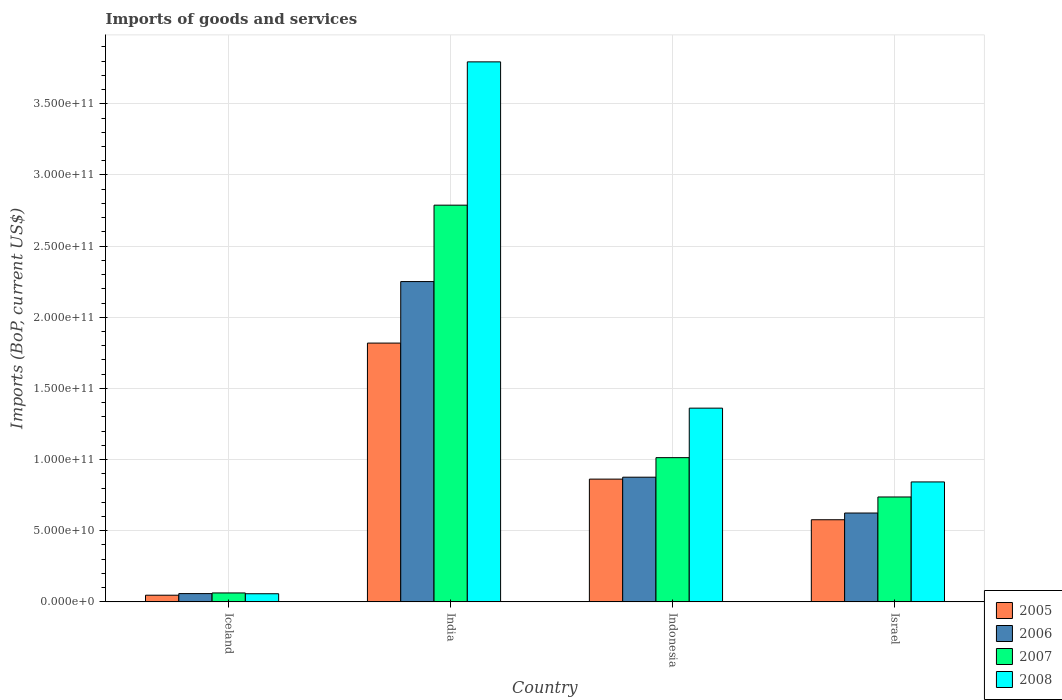What is the label of the 2nd group of bars from the left?
Your response must be concise. India. In how many cases, is the number of bars for a given country not equal to the number of legend labels?
Offer a terse response. 0. What is the amount spent on imports in 2006 in Iceland?
Your answer should be compact. 5.82e+09. Across all countries, what is the maximum amount spent on imports in 2007?
Ensure brevity in your answer.  2.79e+11. Across all countries, what is the minimum amount spent on imports in 2005?
Provide a succinct answer. 4.68e+09. In which country was the amount spent on imports in 2005 maximum?
Offer a very short reply. India. What is the total amount spent on imports in 2007 in the graph?
Provide a succinct answer. 4.60e+11. What is the difference between the amount spent on imports in 2005 in Iceland and that in Israel?
Your response must be concise. -5.30e+1. What is the difference between the amount spent on imports in 2008 in Iceland and the amount spent on imports in 2005 in Israel?
Ensure brevity in your answer.  -5.20e+1. What is the average amount spent on imports in 2007 per country?
Your response must be concise. 1.15e+11. What is the difference between the amount spent on imports of/in 2008 and amount spent on imports of/in 2007 in Israel?
Provide a short and direct response. 1.06e+1. What is the ratio of the amount spent on imports in 2008 in Indonesia to that in Israel?
Offer a terse response. 1.62. What is the difference between the highest and the second highest amount spent on imports in 2008?
Ensure brevity in your answer.  2.43e+11. What is the difference between the highest and the lowest amount spent on imports in 2008?
Make the answer very short. 3.74e+11. Is the sum of the amount spent on imports in 2005 in Iceland and India greater than the maximum amount spent on imports in 2006 across all countries?
Offer a very short reply. No. Is it the case that in every country, the sum of the amount spent on imports in 2008 and amount spent on imports in 2007 is greater than the sum of amount spent on imports in 2006 and amount spent on imports in 2005?
Ensure brevity in your answer.  No. Is it the case that in every country, the sum of the amount spent on imports in 2008 and amount spent on imports in 2006 is greater than the amount spent on imports in 2005?
Make the answer very short. Yes. Does the graph contain grids?
Make the answer very short. Yes. How many legend labels are there?
Ensure brevity in your answer.  4. What is the title of the graph?
Keep it short and to the point. Imports of goods and services. Does "1990" appear as one of the legend labels in the graph?
Your answer should be very brief. No. What is the label or title of the X-axis?
Your answer should be very brief. Country. What is the label or title of the Y-axis?
Keep it short and to the point. Imports (BoP, current US$). What is the Imports (BoP, current US$) in 2005 in Iceland?
Keep it short and to the point. 4.68e+09. What is the Imports (BoP, current US$) of 2006 in Iceland?
Your answer should be compact. 5.82e+09. What is the Imports (BoP, current US$) in 2007 in Iceland?
Your answer should be very brief. 6.27e+09. What is the Imports (BoP, current US$) in 2008 in Iceland?
Your answer should be very brief. 5.71e+09. What is the Imports (BoP, current US$) in 2005 in India?
Your response must be concise. 1.82e+11. What is the Imports (BoP, current US$) of 2006 in India?
Your answer should be very brief. 2.25e+11. What is the Imports (BoP, current US$) of 2007 in India?
Offer a very short reply. 2.79e+11. What is the Imports (BoP, current US$) of 2008 in India?
Ensure brevity in your answer.  3.79e+11. What is the Imports (BoP, current US$) of 2005 in Indonesia?
Keep it short and to the point. 8.63e+1. What is the Imports (BoP, current US$) in 2006 in Indonesia?
Provide a short and direct response. 8.76e+1. What is the Imports (BoP, current US$) of 2007 in Indonesia?
Keep it short and to the point. 1.01e+11. What is the Imports (BoP, current US$) of 2008 in Indonesia?
Give a very brief answer. 1.36e+11. What is the Imports (BoP, current US$) in 2005 in Israel?
Your response must be concise. 5.77e+1. What is the Imports (BoP, current US$) in 2006 in Israel?
Your answer should be compact. 6.24e+1. What is the Imports (BoP, current US$) in 2007 in Israel?
Offer a very short reply. 7.37e+1. What is the Imports (BoP, current US$) of 2008 in Israel?
Your response must be concise. 8.43e+1. Across all countries, what is the maximum Imports (BoP, current US$) of 2005?
Your answer should be compact. 1.82e+11. Across all countries, what is the maximum Imports (BoP, current US$) in 2006?
Provide a short and direct response. 2.25e+11. Across all countries, what is the maximum Imports (BoP, current US$) of 2007?
Give a very brief answer. 2.79e+11. Across all countries, what is the maximum Imports (BoP, current US$) of 2008?
Your answer should be compact. 3.79e+11. Across all countries, what is the minimum Imports (BoP, current US$) of 2005?
Your response must be concise. 4.68e+09. Across all countries, what is the minimum Imports (BoP, current US$) of 2006?
Provide a succinct answer. 5.82e+09. Across all countries, what is the minimum Imports (BoP, current US$) of 2007?
Offer a very short reply. 6.27e+09. Across all countries, what is the minimum Imports (BoP, current US$) of 2008?
Provide a short and direct response. 5.71e+09. What is the total Imports (BoP, current US$) in 2005 in the graph?
Your response must be concise. 3.31e+11. What is the total Imports (BoP, current US$) in 2006 in the graph?
Offer a terse response. 3.81e+11. What is the total Imports (BoP, current US$) of 2007 in the graph?
Offer a very short reply. 4.60e+11. What is the total Imports (BoP, current US$) in 2008 in the graph?
Your answer should be very brief. 6.06e+11. What is the difference between the Imports (BoP, current US$) in 2005 in Iceland and that in India?
Provide a succinct answer. -1.77e+11. What is the difference between the Imports (BoP, current US$) of 2006 in Iceland and that in India?
Make the answer very short. -2.19e+11. What is the difference between the Imports (BoP, current US$) in 2007 in Iceland and that in India?
Offer a very short reply. -2.73e+11. What is the difference between the Imports (BoP, current US$) of 2008 in Iceland and that in India?
Your answer should be very brief. -3.74e+11. What is the difference between the Imports (BoP, current US$) of 2005 in Iceland and that in Indonesia?
Ensure brevity in your answer.  -8.16e+1. What is the difference between the Imports (BoP, current US$) in 2006 in Iceland and that in Indonesia?
Make the answer very short. -8.18e+1. What is the difference between the Imports (BoP, current US$) in 2007 in Iceland and that in Indonesia?
Provide a short and direct response. -9.51e+1. What is the difference between the Imports (BoP, current US$) in 2008 in Iceland and that in Indonesia?
Give a very brief answer. -1.30e+11. What is the difference between the Imports (BoP, current US$) of 2005 in Iceland and that in Israel?
Your answer should be compact. -5.30e+1. What is the difference between the Imports (BoP, current US$) in 2006 in Iceland and that in Israel?
Make the answer very short. -5.66e+1. What is the difference between the Imports (BoP, current US$) of 2007 in Iceland and that in Israel?
Your answer should be very brief. -6.74e+1. What is the difference between the Imports (BoP, current US$) of 2008 in Iceland and that in Israel?
Provide a succinct answer. -7.86e+1. What is the difference between the Imports (BoP, current US$) in 2005 in India and that in Indonesia?
Keep it short and to the point. 9.56e+1. What is the difference between the Imports (BoP, current US$) of 2006 in India and that in Indonesia?
Offer a very short reply. 1.37e+11. What is the difference between the Imports (BoP, current US$) of 2007 in India and that in Indonesia?
Give a very brief answer. 1.77e+11. What is the difference between the Imports (BoP, current US$) of 2008 in India and that in Indonesia?
Provide a short and direct response. 2.43e+11. What is the difference between the Imports (BoP, current US$) of 2005 in India and that in Israel?
Your response must be concise. 1.24e+11. What is the difference between the Imports (BoP, current US$) in 2006 in India and that in Israel?
Keep it short and to the point. 1.63e+11. What is the difference between the Imports (BoP, current US$) of 2007 in India and that in Israel?
Offer a very short reply. 2.05e+11. What is the difference between the Imports (BoP, current US$) in 2008 in India and that in Israel?
Ensure brevity in your answer.  2.95e+11. What is the difference between the Imports (BoP, current US$) of 2005 in Indonesia and that in Israel?
Offer a terse response. 2.86e+1. What is the difference between the Imports (BoP, current US$) in 2006 in Indonesia and that in Israel?
Your response must be concise. 2.52e+1. What is the difference between the Imports (BoP, current US$) of 2007 in Indonesia and that in Israel?
Give a very brief answer. 2.76e+1. What is the difference between the Imports (BoP, current US$) in 2008 in Indonesia and that in Israel?
Your response must be concise. 5.19e+1. What is the difference between the Imports (BoP, current US$) of 2005 in Iceland and the Imports (BoP, current US$) of 2006 in India?
Keep it short and to the point. -2.20e+11. What is the difference between the Imports (BoP, current US$) in 2005 in Iceland and the Imports (BoP, current US$) in 2007 in India?
Provide a succinct answer. -2.74e+11. What is the difference between the Imports (BoP, current US$) of 2005 in Iceland and the Imports (BoP, current US$) of 2008 in India?
Your answer should be very brief. -3.75e+11. What is the difference between the Imports (BoP, current US$) in 2006 in Iceland and the Imports (BoP, current US$) in 2007 in India?
Your response must be concise. -2.73e+11. What is the difference between the Imports (BoP, current US$) of 2006 in Iceland and the Imports (BoP, current US$) of 2008 in India?
Offer a terse response. -3.74e+11. What is the difference between the Imports (BoP, current US$) in 2007 in Iceland and the Imports (BoP, current US$) in 2008 in India?
Provide a short and direct response. -3.73e+11. What is the difference between the Imports (BoP, current US$) in 2005 in Iceland and the Imports (BoP, current US$) in 2006 in Indonesia?
Offer a very short reply. -8.29e+1. What is the difference between the Imports (BoP, current US$) of 2005 in Iceland and the Imports (BoP, current US$) of 2007 in Indonesia?
Your answer should be compact. -9.67e+1. What is the difference between the Imports (BoP, current US$) in 2005 in Iceland and the Imports (BoP, current US$) in 2008 in Indonesia?
Give a very brief answer. -1.31e+11. What is the difference between the Imports (BoP, current US$) of 2006 in Iceland and the Imports (BoP, current US$) of 2007 in Indonesia?
Your answer should be compact. -9.55e+1. What is the difference between the Imports (BoP, current US$) of 2006 in Iceland and the Imports (BoP, current US$) of 2008 in Indonesia?
Provide a short and direct response. -1.30e+11. What is the difference between the Imports (BoP, current US$) in 2007 in Iceland and the Imports (BoP, current US$) in 2008 in Indonesia?
Ensure brevity in your answer.  -1.30e+11. What is the difference between the Imports (BoP, current US$) in 2005 in Iceland and the Imports (BoP, current US$) in 2006 in Israel?
Provide a short and direct response. -5.78e+1. What is the difference between the Imports (BoP, current US$) of 2005 in Iceland and the Imports (BoP, current US$) of 2007 in Israel?
Your response must be concise. -6.90e+1. What is the difference between the Imports (BoP, current US$) of 2005 in Iceland and the Imports (BoP, current US$) of 2008 in Israel?
Provide a succinct answer. -7.96e+1. What is the difference between the Imports (BoP, current US$) of 2006 in Iceland and the Imports (BoP, current US$) of 2007 in Israel?
Your answer should be compact. -6.79e+1. What is the difference between the Imports (BoP, current US$) in 2006 in Iceland and the Imports (BoP, current US$) in 2008 in Israel?
Keep it short and to the point. -7.85e+1. What is the difference between the Imports (BoP, current US$) of 2007 in Iceland and the Imports (BoP, current US$) of 2008 in Israel?
Your answer should be very brief. -7.80e+1. What is the difference between the Imports (BoP, current US$) in 2005 in India and the Imports (BoP, current US$) in 2006 in Indonesia?
Your answer should be compact. 9.42e+1. What is the difference between the Imports (BoP, current US$) of 2005 in India and the Imports (BoP, current US$) of 2007 in Indonesia?
Your answer should be very brief. 8.05e+1. What is the difference between the Imports (BoP, current US$) of 2005 in India and the Imports (BoP, current US$) of 2008 in Indonesia?
Provide a short and direct response. 4.57e+1. What is the difference between the Imports (BoP, current US$) of 2006 in India and the Imports (BoP, current US$) of 2007 in Indonesia?
Provide a short and direct response. 1.24e+11. What is the difference between the Imports (BoP, current US$) of 2006 in India and the Imports (BoP, current US$) of 2008 in Indonesia?
Offer a very short reply. 8.89e+1. What is the difference between the Imports (BoP, current US$) of 2007 in India and the Imports (BoP, current US$) of 2008 in Indonesia?
Give a very brief answer. 1.43e+11. What is the difference between the Imports (BoP, current US$) of 2005 in India and the Imports (BoP, current US$) of 2006 in Israel?
Your answer should be compact. 1.19e+11. What is the difference between the Imports (BoP, current US$) of 2005 in India and the Imports (BoP, current US$) of 2007 in Israel?
Offer a terse response. 1.08e+11. What is the difference between the Imports (BoP, current US$) of 2005 in India and the Imports (BoP, current US$) of 2008 in Israel?
Your answer should be compact. 9.76e+1. What is the difference between the Imports (BoP, current US$) of 2006 in India and the Imports (BoP, current US$) of 2007 in Israel?
Your answer should be compact. 1.51e+11. What is the difference between the Imports (BoP, current US$) in 2006 in India and the Imports (BoP, current US$) in 2008 in Israel?
Ensure brevity in your answer.  1.41e+11. What is the difference between the Imports (BoP, current US$) in 2007 in India and the Imports (BoP, current US$) in 2008 in Israel?
Provide a short and direct response. 1.95e+11. What is the difference between the Imports (BoP, current US$) of 2005 in Indonesia and the Imports (BoP, current US$) of 2006 in Israel?
Your answer should be very brief. 2.38e+1. What is the difference between the Imports (BoP, current US$) of 2005 in Indonesia and the Imports (BoP, current US$) of 2007 in Israel?
Your answer should be very brief. 1.26e+1. What is the difference between the Imports (BoP, current US$) in 2005 in Indonesia and the Imports (BoP, current US$) in 2008 in Israel?
Give a very brief answer. 1.98e+09. What is the difference between the Imports (BoP, current US$) of 2006 in Indonesia and the Imports (BoP, current US$) of 2007 in Israel?
Your answer should be very brief. 1.39e+1. What is the difference between the Imports (BoP, current US$) of 2006 in Indonesia and the Imports (BoP, current US$) of 2008 in Israel?
Give a very brief answer. 3.33e+09. What is the difference between the Imports (BoP, current US$) of 2007 in Indonesia and the Imports (BoP, current US$) of 2008 in Israel?
Provide a short and direct response. 1.71e+1. What is the average Imports (BoP, current US$) in 2005 per country?
Provide a succinct answer. 8.26e+1. What is the average Imports (BoP, current US$) in 2006 per country?
Make the answer very short. 9.52e+1. What is the average Imports (BoP, current US$) in 2007 per country?
Provide a succinct answer. 1.15e+11. What is the average Imports (BoP, current US$) of 2008 per country?
Ensure brevity in your answer.  1.51e+11. What is the difference between the Imports (BoP, current US$) in 2005 and Imports (BoP, current US$) in 2006 in Iceland?
Keep it short and to the point. -1.13e+09. What is the difference between the Imports (BoP, current US$) of 2005 and Imports (BoP, current US$) of 2007 in Iceland?
Make the answer very short. -1.59e+09. What is the difference between the Imports (BoP, current US$) of 2005 and Imports (BoP, current US$) of 2008 in Iceland?
Ensure brevity in your answer.  -1.03e+09. What is the difference between the Imports (BoP, current US$) in 2006 and Imports (BoP, current US$) in 2007 in Iceland?
Offer a very short reply. -4.53e+08. What is the difference between the Imports (BoP, current US$) in 2006 and Imports (BoP, current US$) in 2008 in Iceland?
Your answer should be compact. 1.07e+08. What is the difference between the Imports (BoP, current US$) of 2007 and Imports (BoP, current US$) of 2008 in Iceland?
Offer a very short reply. 5.60e+08. What is the difference between the Imports (BoP, current US$) in 2005 and Imports (BoP, current US$) in 2006 in India?
Offer a very short reply. -4.32e+1. What is the difference between the Imports (BoP, current US$) of 2005 and Imports (BoP, current US$) of 2007 in India?
Offer a very short reply. -9.69e+1. What is the difference between the Imports (BoP, current US$) of 2005 and Imports (BoP, current US$) of 2008 in India?
Give a very brief answer. -1.98e+11. What is the difference between the Imports (BoP, current US$) of 2006 and Imports (BoP, current US$) of 2007 in India?
Offer a very short reply. -5.37e+1. What is the difference between the Imports (BoP, current US$) in 2006 and Imports (BoP, current US$) in 2008 in India?
Keep it short and to the point. -1.54e+11. What is the difference between the Imports (BoP, current US$) in 2007 and Imports (BoP, current US$) in 2008 in India?
Your response must be concise. -1.01e+11. What is the difference between the Imports (BoP, current US$) of 2005 and Imports (BoP, current US$) of 2006 in Indonesia?
Ensure brevity in your answer.  -1.35e+09. What is the difference between the Imports (BoP, current US$) in 2005 and Imports (BoP, current US$) in 2007 in Indonesia?
Your answer should be very brief. -1.51e+1. What is the difference between the Imports (BoP, current US$) in 2005 and Imports (BoP, current US$) in 2008 in Indonesia?
Ensure brevity in your answer.  -4.99e+1. What is the difference between the Imports (BoP, current US$) in 2006 and Imports (BoP, current US$) in 2007 in Indonesia?
Offer a very short reply. -1.37e+1. What is the difference between the Imports (BoP, current US$) of 2006 and Imports (BoP, current US$) of 2008 in Indonesia?
Give a very brief answer. -4.85e+1. What is the difference between the Imports (BoP, current US$) in 2007 and Imports (BoP, current US$) in 2008 in Indonesia?
Ensure brevity in your answer.  -3.48e+1. What is the difference between the Imports (BoP, current US$) of 2005 and Imports (BoP, current US$) of 2006 in Israel?
Make the answer very short. -4.73e+09. What is the difference between the Imports (BoP, current US$) of 2005 and Imports (BoP, current US$) of 2007 in Israel?
Your answer should be compact. -1.60e+1. What is the difference between the Imports (BoP, current US$) in 2005 and Imports (BoP, current US$) in 2008 in Israel?
Keep it short and to the point. -2.66e+1. What is the difference between the Imports (BoP, current US$) in 2006 and Imports (BoP, current US$) in 2007 in Israel?
Provide a short and direct response. -1.13e+1. What is the difference between the Imports (BoP, current US$) of 2006 and Imports (BoP, current US$) of 2008 in Israel?
Make the answer very short. -2.18e+1. What is the difference between the Imports (BoP, current US$) in 2007 and Imports (BoP, current US$) in 2008 in Israel?
Offer a terse response. -1.06e+1. What is the ratio of the Imports (BoP, current US$) of 2005 in Iceland to that in India?
Make the answer very short. 0.03. What is the ratio of the Imports (BoP, current US$) in 2006 in Iceland to that in India?
Offer a very short reply. 0.03. What is the ratio of the Imports (BoP, current US$) in 2007 in Iceland to that in India?
Give a very brief answer. 0.02. What is the ratio of the Imports (BoP, current US$) in 2008 in Iceland to that in India?
Offer a very short reply. 0.01. What is the ratio of the Imports (BoP, current US$) in 2005 in Iceland to that in Indonesia?
Offer a terse response. 0.05. What is the ratio of the Imports (BoP, current US$) in 2006 in Iceland to that in Indonesia?
Your response must be concise. 0.07. What is the ratio of the Imports (BoP, current US$) of 2007 in Iceland to that in Indonesia?
Keep it short and to the point. 0.06. What is the ratio of the Imports (BoP, current US$) in 2008 in Iceland to that in Indonesia?
Your answer should be very brief. 0.04. What is the ratio of the Imports (BoP, current US$) in 2005 in Iceland to that in Israel?
Keep it short and to the point. 0.08. What is the ratio of the Imports (BoP, current US$) of 2006 in Iceland to that in Israel?
Provide a short and direct response. 0.09. What is the ratio of the Imports (BoP, current US$) of 2007 in Iceland to that in Israel?
Offer a terse response. 0.09. What is the ratio of the Imports (BoP, current US$) of 2008 in Iceland to that in Israel?
Keep it short and to the point. 0.07. What is the ratio of the Imports (BoP, current US$) of 2005 in India to that in Indonesia?
Offer a terse response. 2.11. What is the ratio of the Imports (BoP, current US$) in 2006 in India to that in Indonesia?
Offer a terse response. 2.57. What is the ratio of the Imports (BoP, current US$) in 2007 in India to that in Indonesia?
Make the answer very short. 2.75. What is the ratio of the Imports (BoP, current US$) of 2008 in India to that in Indonesia?
Give a very brief answer. 2.79. What is the ratio of the Imports (BoP, current US$) of 2005 in India to that in Israel?
Your response must be concise. 3.15. What is the ratio of the Imports (BoP, current US$) in 2006 in India to that in Israel?
Provide a succinct answer. 3.6. What is the ratio of the Imports (BoP, current US$) in 2007 in India to that in Israel?
Offer a very short reply. 3.78. What is the ratio of the Imports (BoP, current US$) of 2008 in India to that in Israel?
Ensure brevity in your answer.  4.5. What is the ratio of the Imports (BoP, current US$) of 2005 in Indonesia to that in Israel?
Your response must be concise. 1.49. What is the ratio of the Imports (BoP, current US$) in 2006 in Indonesia to that in Israel?
Your response must be concise. 1.4. What is the ratio of the Imports (BoP, current US$) of 2007 in Indonesia to that in Israel?
Your answer should be compact. 1.37. What is the ratio of the Imports (BoP, current US$) of 2008 in Indonesia to that in Israel?
Make the answer very short. 1.62. What is the difference between the highest and the second highest Imports (BoP, current US$) in 2005?
Provide a succinct answer. 9.56e+1. What is the difference between the highest and the second highest Imports (BoP, current US$) of 2006?
Provide a short and direct response. 1.37e+11. What is the difference between the highest and the second highest Imports (BoP, current US$) in 2007?
Your answer should be compact. 1.77e+11. What is the difference between the highest and the second highest Imports (BoP, current US$) in 2008?
Provide a short and direct response. 2.43e+11. What is the difference between the highest and the lowest Imports (BoP, current US$) of 2005?
Make the answer very short. 1.77e+11. What is the difference between the highest and the lowest Imports (BoP, current US$) in 2006?
Make the answer very short. 2.19e+11. What is the difference between the highest and the lowest Imports (BoP, current US$) in 2007?
Provide a succinct answer. 2.73e+11. What is the difference between the highest and the lowest Imports (BoP, current US$) in 2008?
Give a very brief answer. 3.74e+11. 